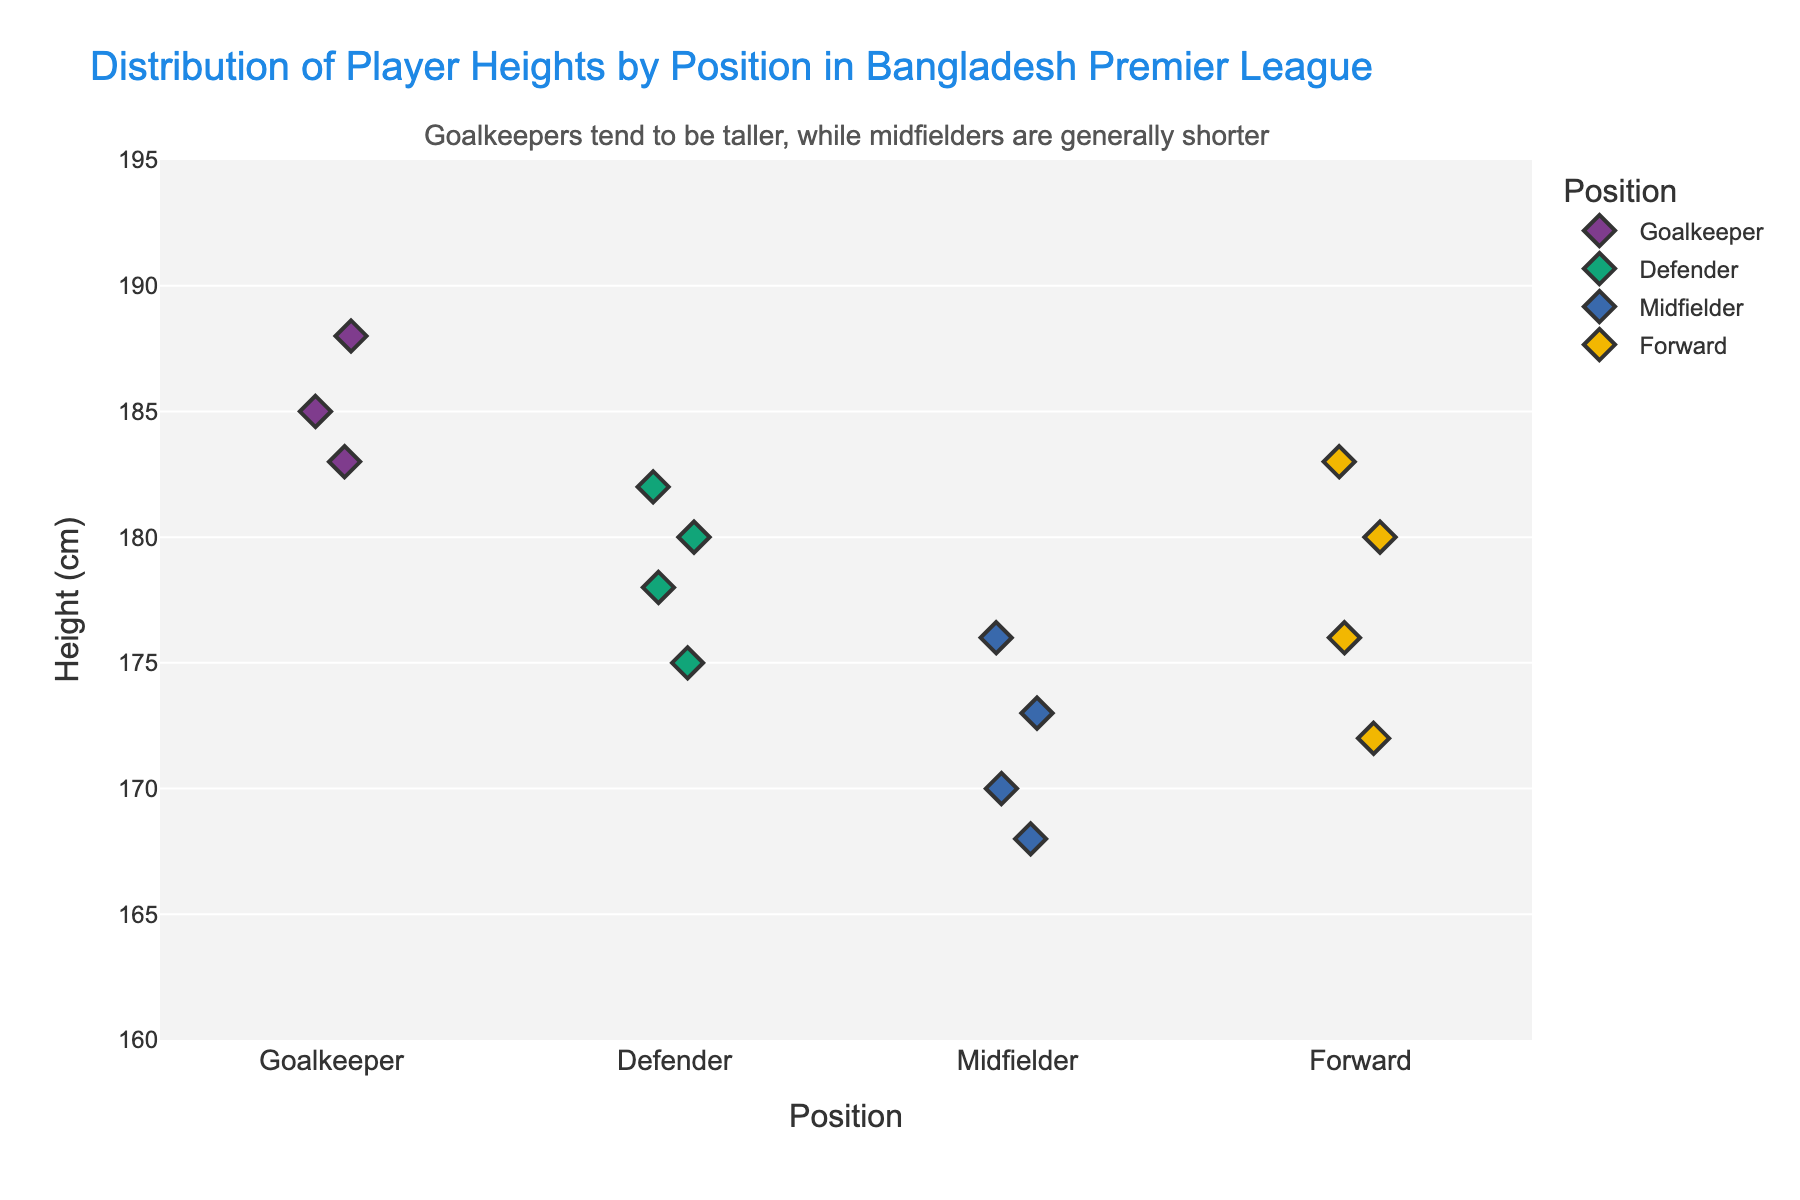How many players are plotted for the Forward position? There are four diamond-shaped markers under the Forward position.
Answer: 4 Which position has the tallest player and what is their height? The tallest diamond marker is under the Goalkeeper position at 188 cm.
Answer: Goalkeeper, 188 cm What's the average height of players in the Defender position? The heights of Defenders are 182 cm, 180 cm, 178 cm, and 175 cm. Adding them gives 715 cm, and dividing by 4 yields 178.75 cm.
Answer: 178.75 cm What’s the general trend observed between player positions and their heights? The annotation in the figure notes that Goalkeepers tend to be taller, while Midfielders are generally shorter. Visual inspection shows taller players are Goalkeepers and shorter players are Midfielders.
Answer: Goalkeepers are taller, Midfielders are shorter What range of heights is observed for Midfielders? The diamond markers for Midfielders range from the lowest at 168 cm to the highest at 176 cm.
Answer: 168 cm to 176 cm What's the difference in height between the tallest Forward and the shortest Midfielder? The tallest Forward is 183 cm and the shortest Midfielder is 168 cm. The difference is 183 cm - 168 cm = 15 cm.
Answer: 15 cm Which position has the most closely clustered heights? By visually inspecting, the diamond markers for Midfielders are most closely clustered together compared to other positions.
Answer: Midfielders Are there any positions where the players have the same height? Checking each position, there are no overlapping diamond markers indicating equal heights.
Answer: No Compare the number of players in the Midfielder position to those in the Goalkeeper position. Midfielders have 4 players, and Goalkeepers have 3 players, so Midfielders have one more.
Answer: Midfielders have one more player What is the median height for the Forward players? Forward heights are 183 cm, 180 cm, 176 cm, and 172 cm. Ordering and finding the median gives (176 + 180) / 2 = 178 cm.
Answer: 178 cm 